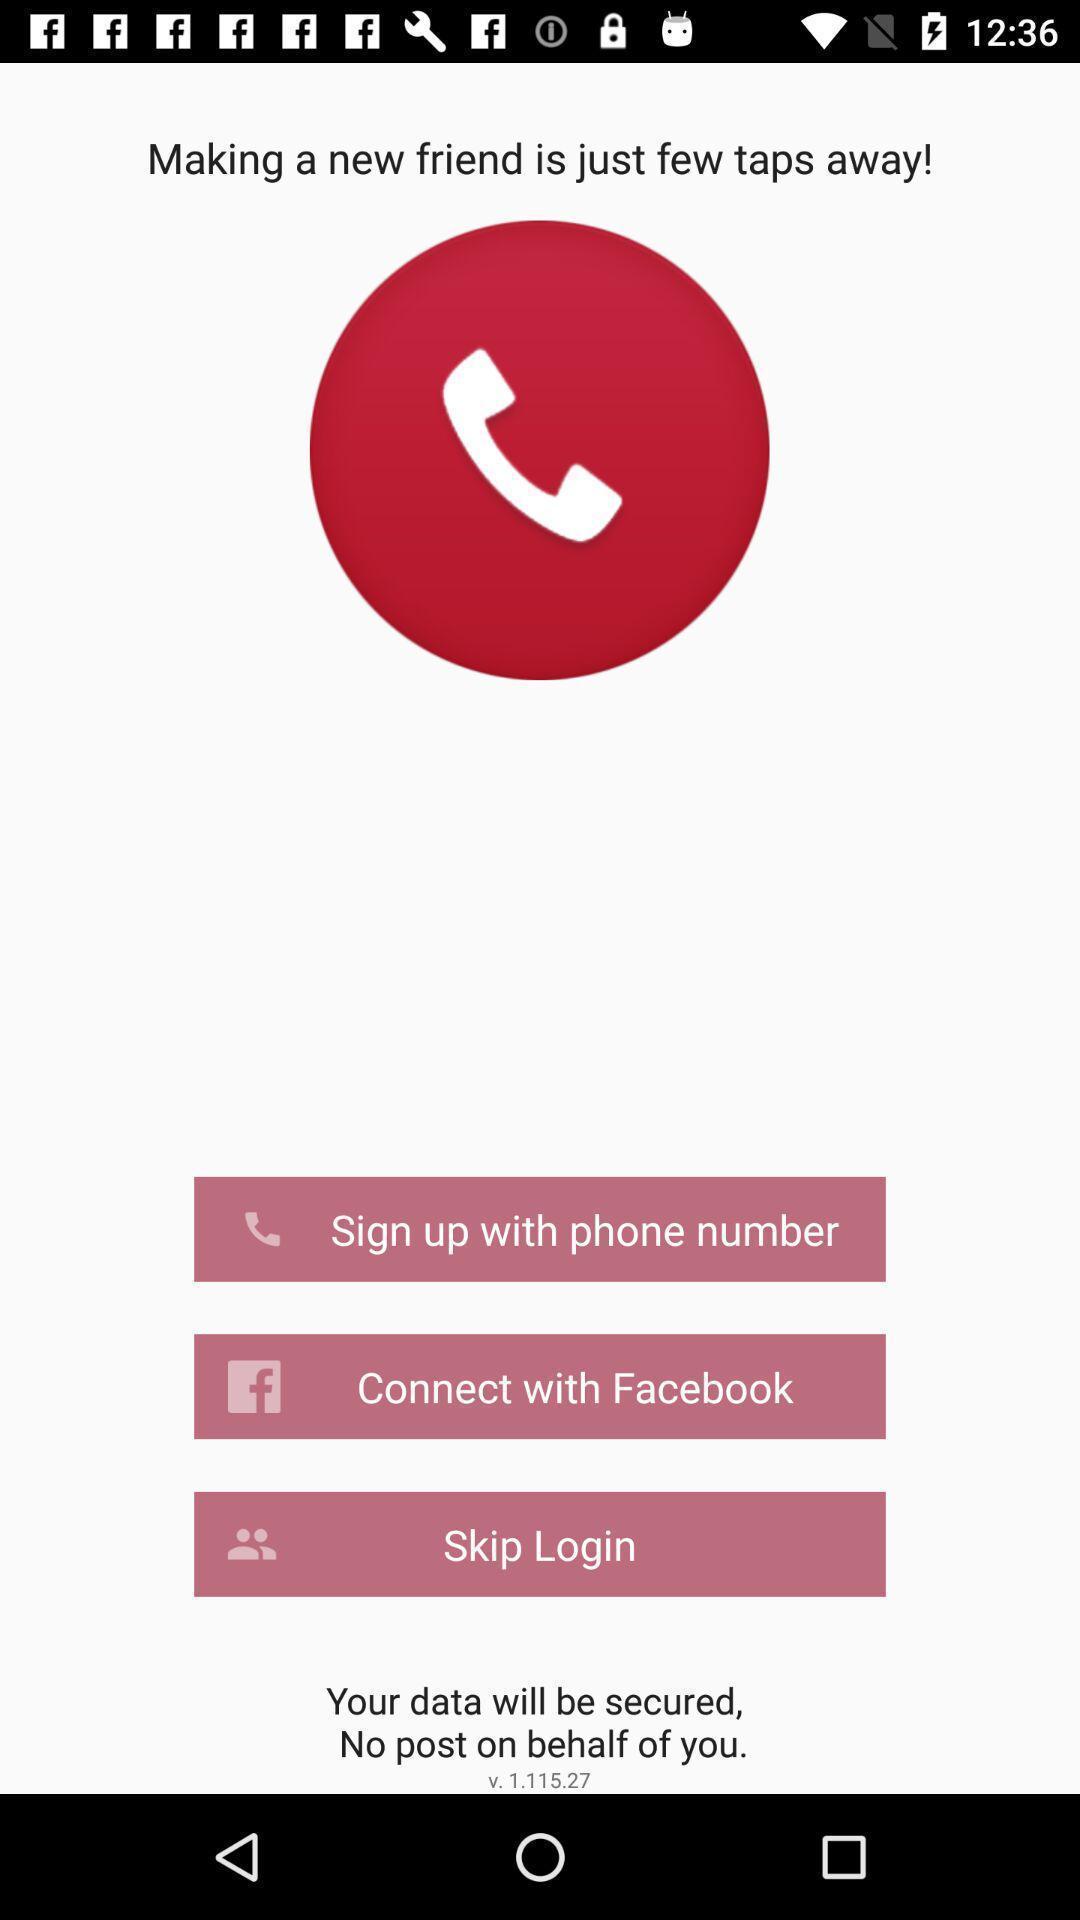Summarize the main components in this picture. Welcome page. 